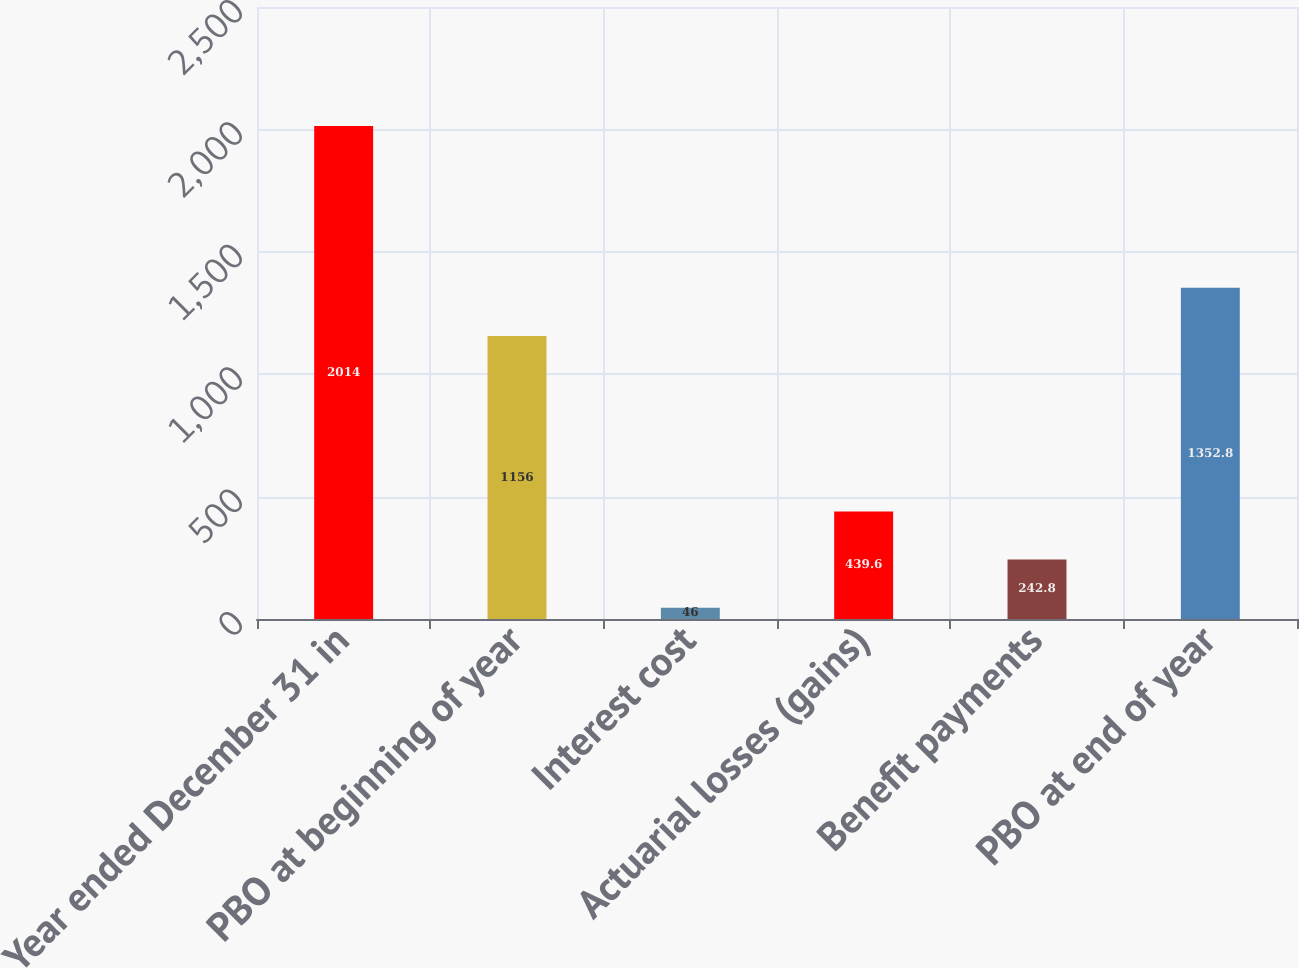Convert chart. <chart><loc_0><loc_0><loc_500><loc_500><bar_chart><fcel>Year ended December 31 in<fcel>PBO at beginning of year<fcel>Interest cost<fcel>Actuarial losses (gains)<fcel>Benefit payments<fcel>PBO at end of year<nl><fcel>2014<fcel>1156<fcel>46<fcel>439.6<fcel>242.8<fcel>1352.8<nl></chart> 